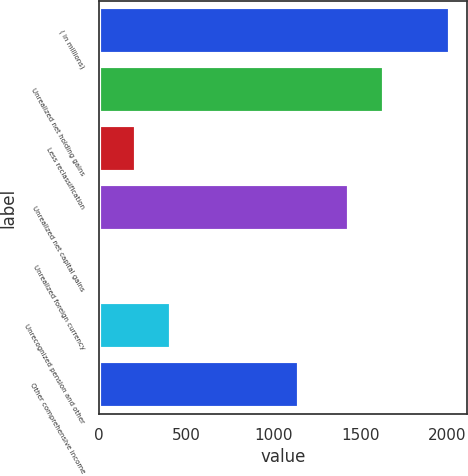Convert chart. <chart><loc_0><loc_0><loc_500><loc_500><bar_chart><fcel>( in millions)<fcel>Unrealized net holding gains<fcel>Less reclassification<fcel>Unrealized net capital gains<fcel>Unrealized foreign currency<fcel>Unrecognized pension and other<fcel>Other comprehensive income<nl><fcel>2012<fcel>1633.8<fcel>213.8<fcel>1434<fcel>14<fcel>413.6<fcel>1146<nl></chart> 